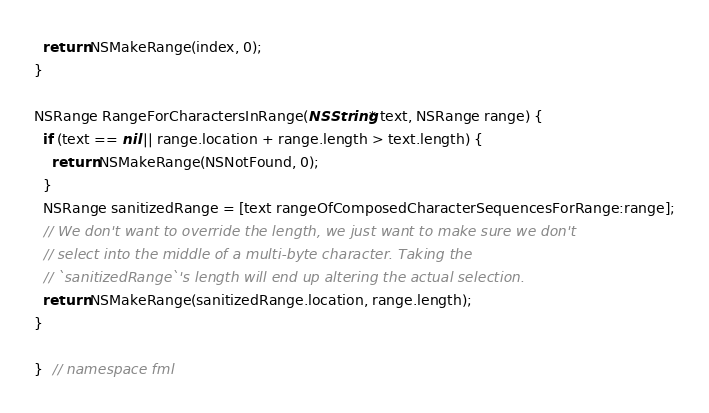<code> <loc_0><loc_0><loc_500><loc_500><_ObjectiveC_>  return NSMakeRange(index, 0);
}

NSRange RangeForCharactersInRange(NSString* text, NSRange range) {
  if (text == nil || range.location + range.length > text.length) {
    return NSMakeRange(NSNotFound, 0);
  }
  NSRange sanitizedRange = [text rangeOfComposedCharacterSequencesForRange:range];
  // We don't want to override the length, we just want to make sure we don't
  // select into the middle of a multi-byte character. Taking the
  // `sanitizedRange`'s length will end up altering the actual selection.
  return NSMakeRange(sanitizedRange.location, range.length);
}

}  // namespace fml
</code> 